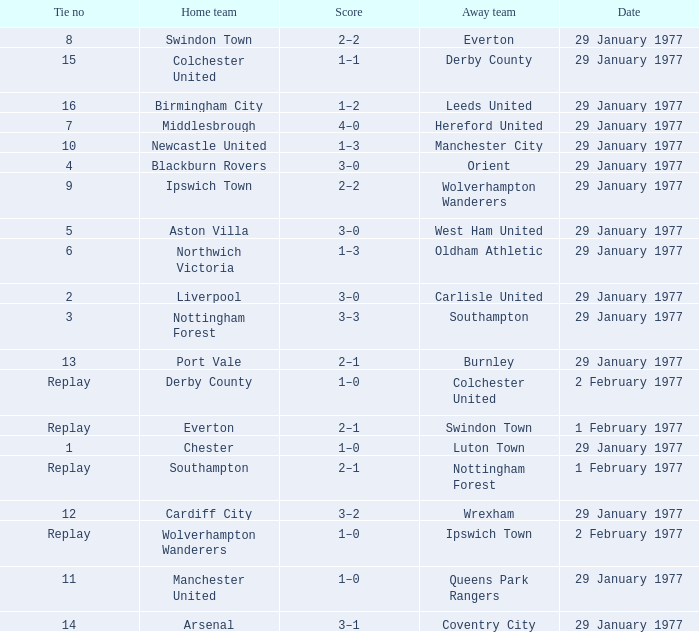Which away team has a tie number of 3? Southampton. 